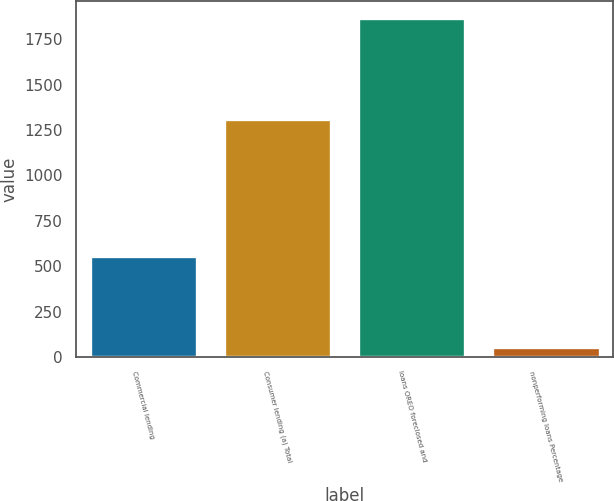Convert chart to OTSL. <chart><loc_0><loc_0><loc_500><loc_500><bar_chart><fcel>Commercial lending<fcel>Consumer lending (a) Total<fcel>loans OREO foreclosed and<fcel>nonperforming loans Percentage<nl><fcel>554<fcel>1311<fcel>1865<fcel>52<nl></chart> 